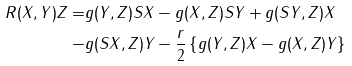Convert formula to latex. <formula><loc_0><loc_0><loc_500><loc_500>R ( X , Y ) Z = & g ( Y , Z ) S X - g ( X , Z ) S Y + g ( S Y , Z ) X \\ - & g ( S X , Z ) Y - \frac { r } { 2 } \left \{ g ( Y , Z ) X - g ( X , Z ) Y \right \}</formula> 